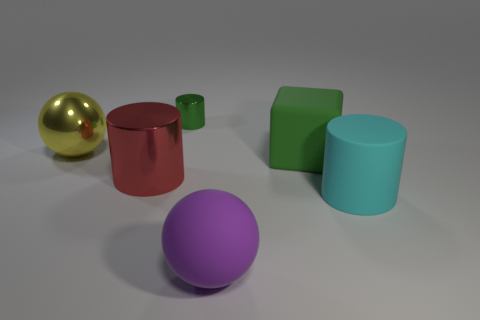Subtract all big cylinders. How many cylinders are left? 1 Add 2 brown metal things. How many objects exist? 8 Subtract all cyan cylinders. How many cylinders are left? 2 Subtract all spheres. How many objects are left? 4 Subtract 2 cylinders. How many cylinders are left? 1 Subtract all purple cubes. Subtract all cyan balls. How many cubes are left? 1 Subtract all blue spheres. How many purple cubes are left? 0 Subtract all small brown balls. Subtract all big objects. How many objects are left? 1 Add 3 big green matte objects. How many big green matte objects are left? 4 Add 3 cyan matte cubes. How many cyan matte cubes exist? 3 